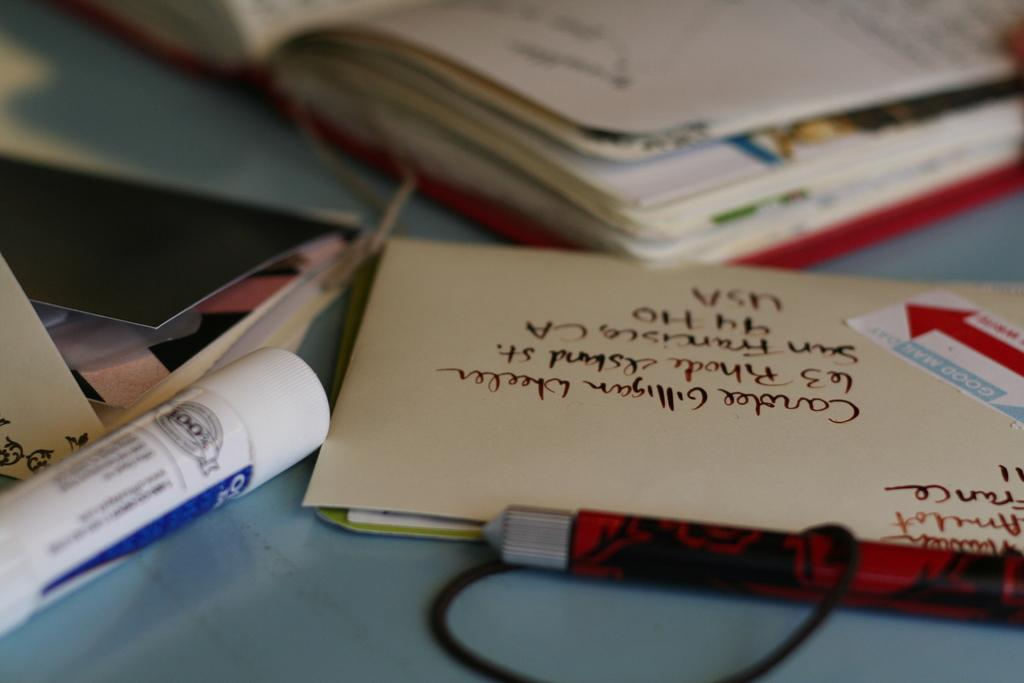<image>
Present a compact description of the photo's key features. An envelope is addressed to an address in the USA. 